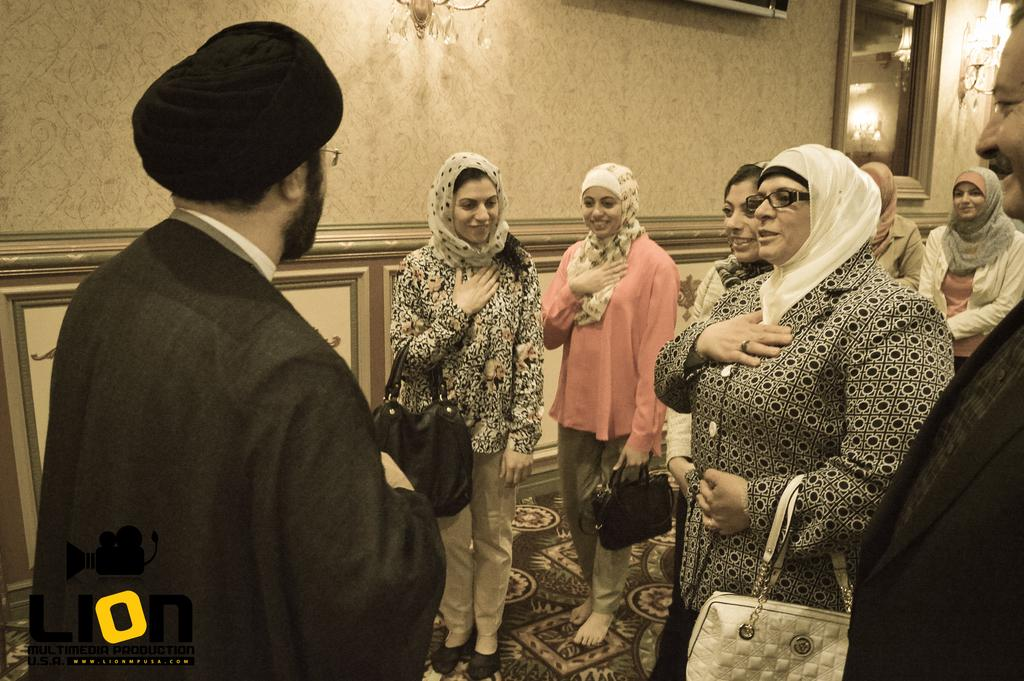How many people are in the image? There are multiple persons standing on the floor. What are the persons holding in the image? The persons are holding bags. What can be seen in the background of the image? There is a light, a television, and a wall in the background. What type of van is parked in front of the wall in the image? There is no van present in the image; only the persons, bags, light, television, and wall are visible. 